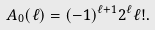<formula> <loc_0><loc_0><loc_500><loc_500>A _ { 0 } ( \ell ) = ( - 1 ) ^ { \ell + 1 } 2 ^ { \ell } \ell ! .</formula> 